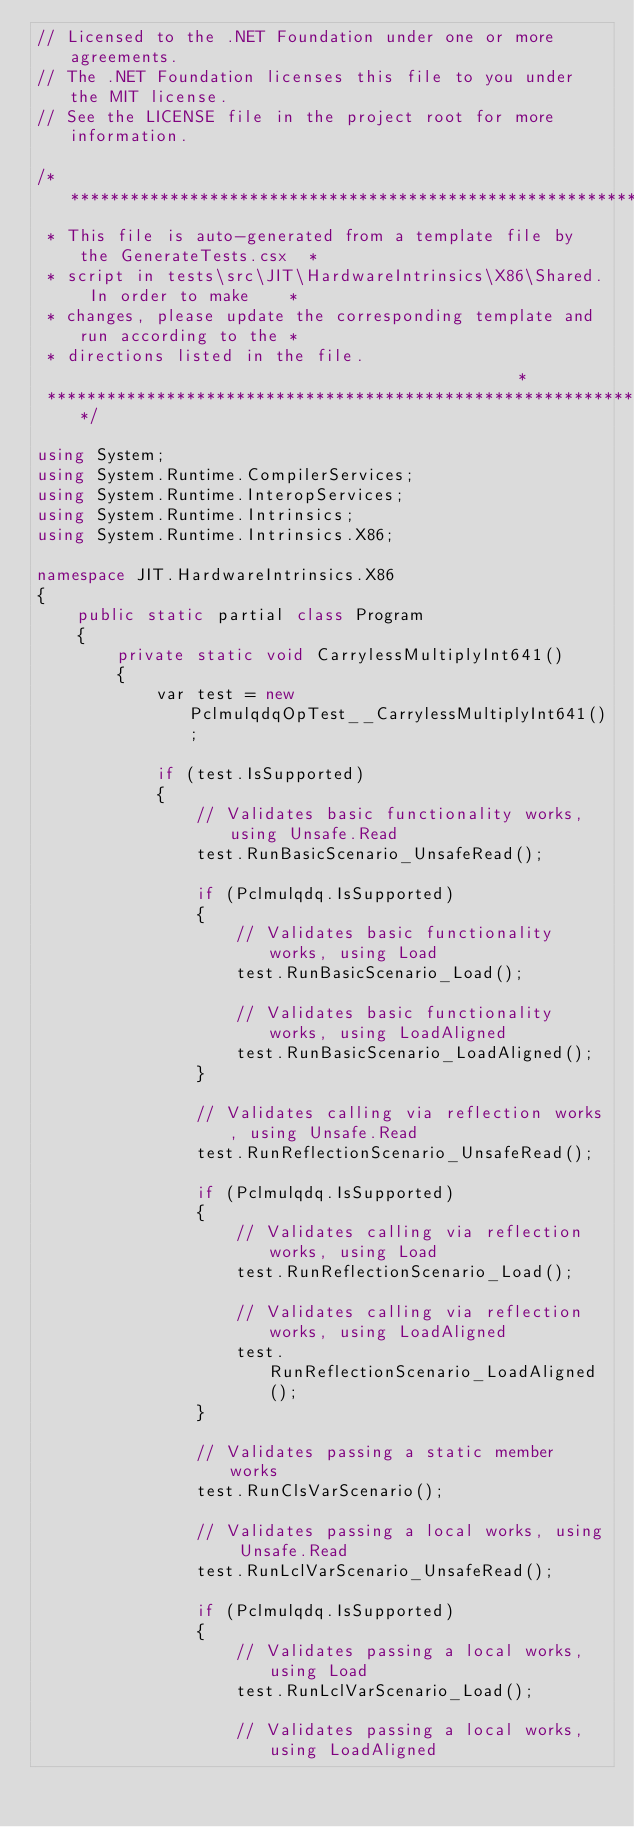Convert code to text. <code><loc_0><loc_0><loc_500><loc_500><_C#_>// Licensed to the .NET Foundation under one or more agreements.
// The .NET Foundation licenses this file to you under the MIT license.
// See the LICENSE file in the project root for more information.

/******************************************************************************
 * This file is auto-generated from a template file by the GenerateTests.csx  *
 * script in tests\src\JIT\HardwareIntrinsics\X86\Shared. In order to make    *
 * changes, please update the corresponding template and run according to the *
 * directions listed in the file.                                             *
 ******************************************************************************/

using System;
using System.Runtime.CompilerServices;
using System.Runtime.InteropServices;
using System.Runtime.Intrinsics;
using System.Runtime.Intrinsics.X86;

namespace JIT.HardwareIntrinsics.X86
{
    public static partial class Program
    {
        private static void CarrylessMultiplyInt641()
        {
            var test = new PclmulqdqOpTest__CarrylessMultiplyInt641();

            if (test.IsSupported)
            {
                // Validates basic functionality works, using Unsafe.Read
                test.RunBasicScenario_UnsafeRead();

                if (Pclmulqdq.IsSupported)
                {
                    // Validates basic functionality works, using Load
                    test.RunBasicScenario_Load();

                    // Validates basic functionality works, using LoadAligned
                    test.RunBasicScenario_LoadAligned();
                }

                // Validates calling via reflection works, using Unsafe.Read
                test.RunReflectionScenario_UnsafeRead();

                if (Pclmulqdq.IsSupported)
                {
                    // Validates calling via reflection works, using Load
                    test.RunReflectionScenario_Load();

                    // Validates calling via reflection works, using LoadAligned
                    test.RunReflectionScenario_LoadAligned();
                }

                // Validates passing a static member works
                test.RunClsVarScenario();

                // Validates passing a local works, using Unsafe.Read
                test.RunLclVarScenario_UnsafeRead();

                if (Pclmulqdq.IsSupported)
                {
                    // Validates passing a local works, using Load
                    test.RunLclVarScenario_Load();

                    // Validates passing a local works, using LoadAligned</code> 